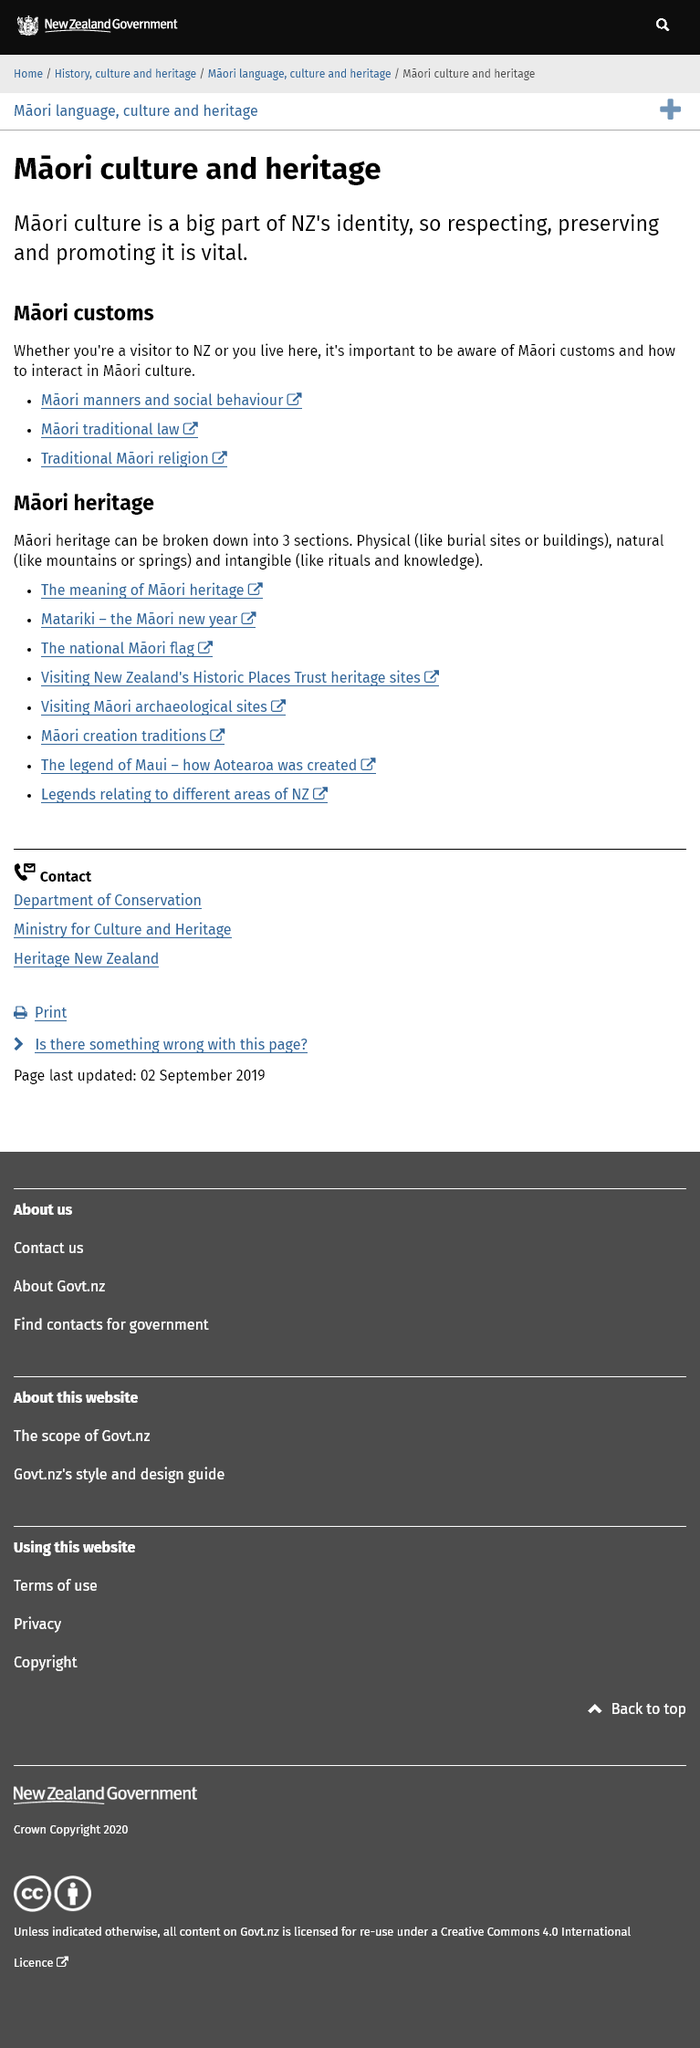Draw attention to some important aspects in this diagram. Any individual who resides in or visits New Zealand is likely to engage with Maori culture and customs. The importance of Maori culture lies in its significant contribution to the identity of New Zealand, making it a crucial aspect of the country's heritage and history. The preservation of Maori heritage is crucial to the identity of New Zealand and should be a top priority for all citizens. 